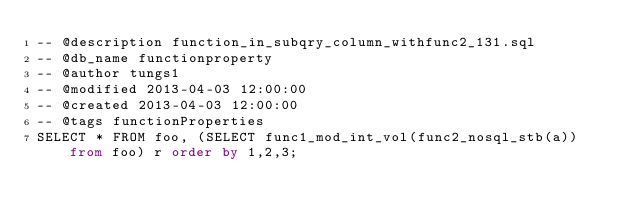Convert code to text. <code><loc_0><loc_0><loc_500><loc_500><_SQL_>-- @description function_in_subqry_column_withfunc2_131.sql
-- @db_name functionproperty
-- @author tungs1
-- @modified 2013-04-03 12:00:00
-- @created 2013-04-03 12:00:00
-- @tags functionProperties 
SELECT * FROM foo, (SELECT func1_mod_int_vol(func2_nosql_stb(a)) from foo) r order by 1,2,3; 
</code> 